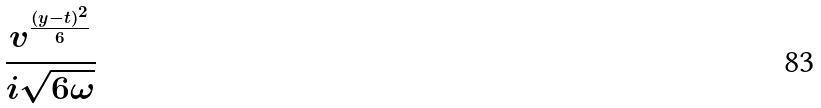Convert formula to latex. <formula><loc_0><loc_0><loc_500><loc_500>\frac { v ^ { \frac { ( y - t ) ^ { 2 } } { 6 } } } { i \sqrt { 6 \omega } }</formula> 